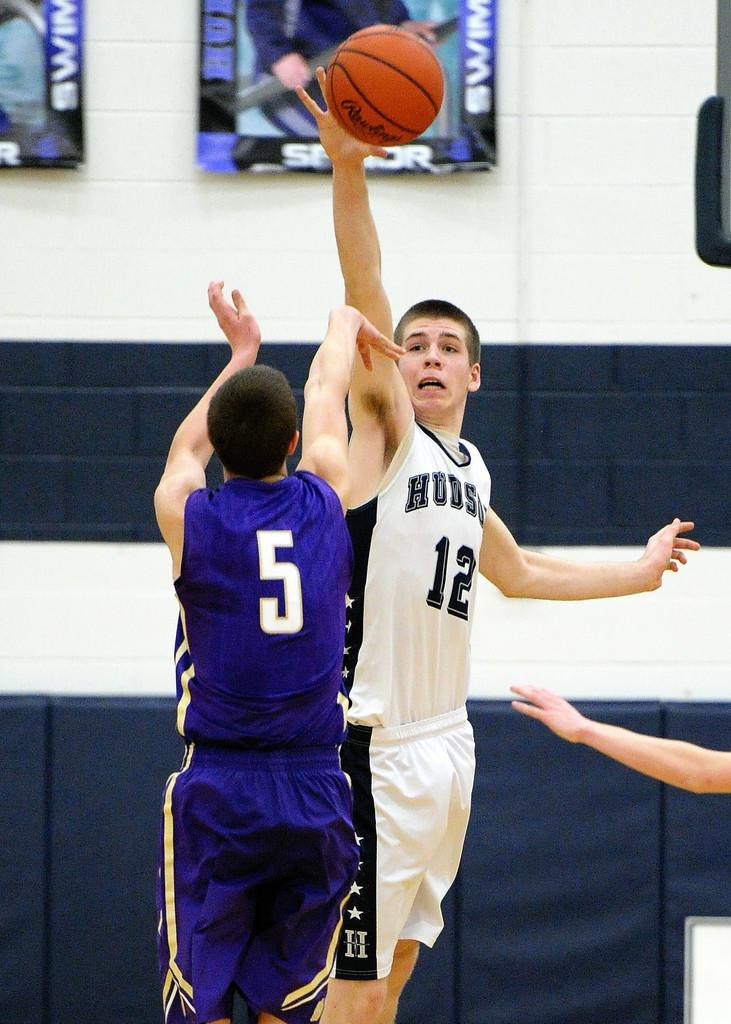<image>
Describe the image concisely. A Hudson basketball player goes for the Rawlings basketball over his opponent. 